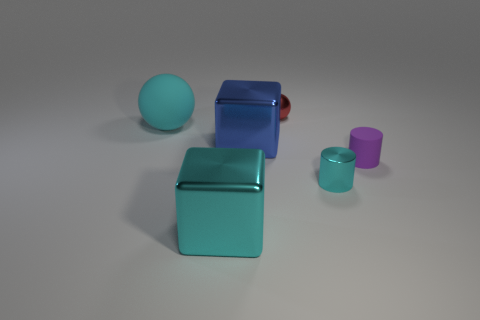Add 2 shiny things. How many objects exist? 8 Subtract 0 green blocks. How many objects are left? 6 Subtract all cylinders. How many objects are left? 4 Subtract 1 blocks. How many blocks are left? 1 Subtract all yellow cylinders. Subtract all gray cubes. How many cylinders are left? 2 Subtract all red blocks. How many green spheres are left? 0 Subtract all small rubber objects. Subtract all large spheres. How many objects are left? 4 Add 2 purple objects. How many purple objects are left? 3 Add 5 red rubber objects. How many red rubber objects exist? 5 Subtract all blue cubes. How many cubes are left? 1 